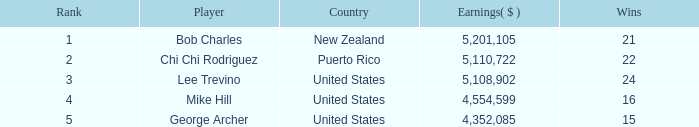What was the total earnings of george archer, the american player, who had less than 24 wins and a rank above 5? 0.0. 